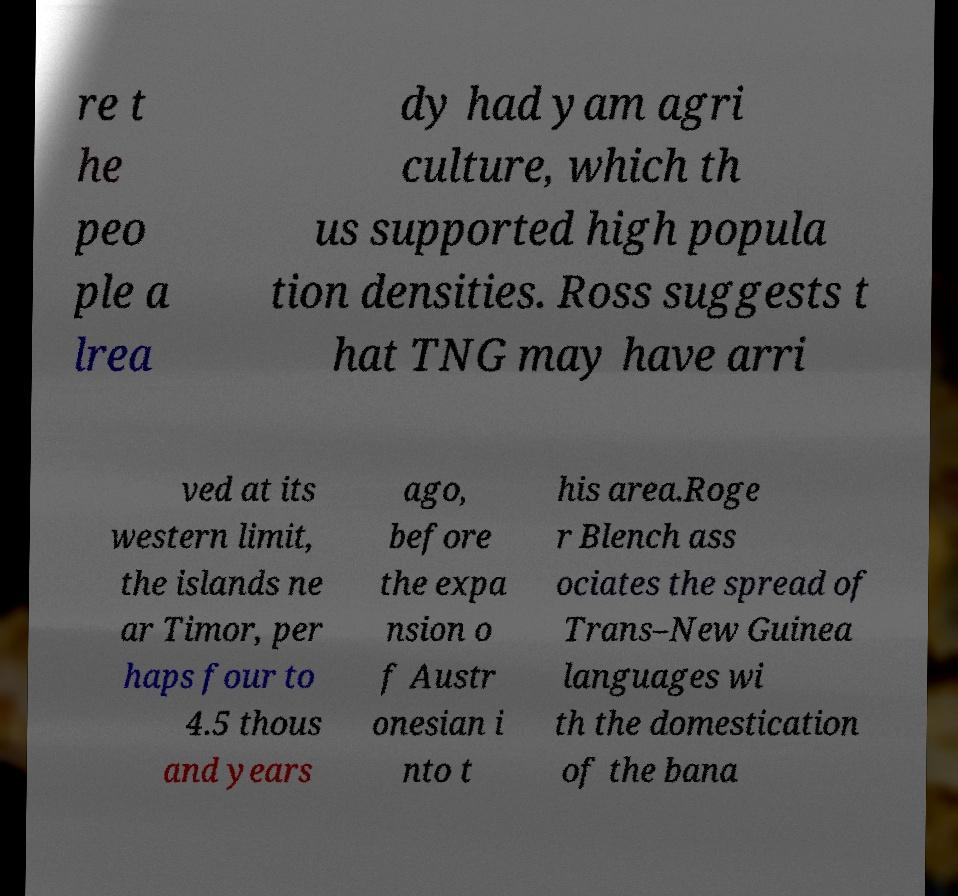For documentation purposes, I need the text within this image transcribed. Could you provide that? re t he peo ple a lrea dy had yam agri culture, which th us supported high popula tion densities. Ross suggests t hat TNG may have arri ved at its western limit, the islands ne ar Timor, per haps four to 4.5 thous and years ago, before the expa nsion o f Austr onesian i nto t his area.Roge r Blench ass ociates the spread of Trans–New Guinea languages wi th the domestication of the bana 